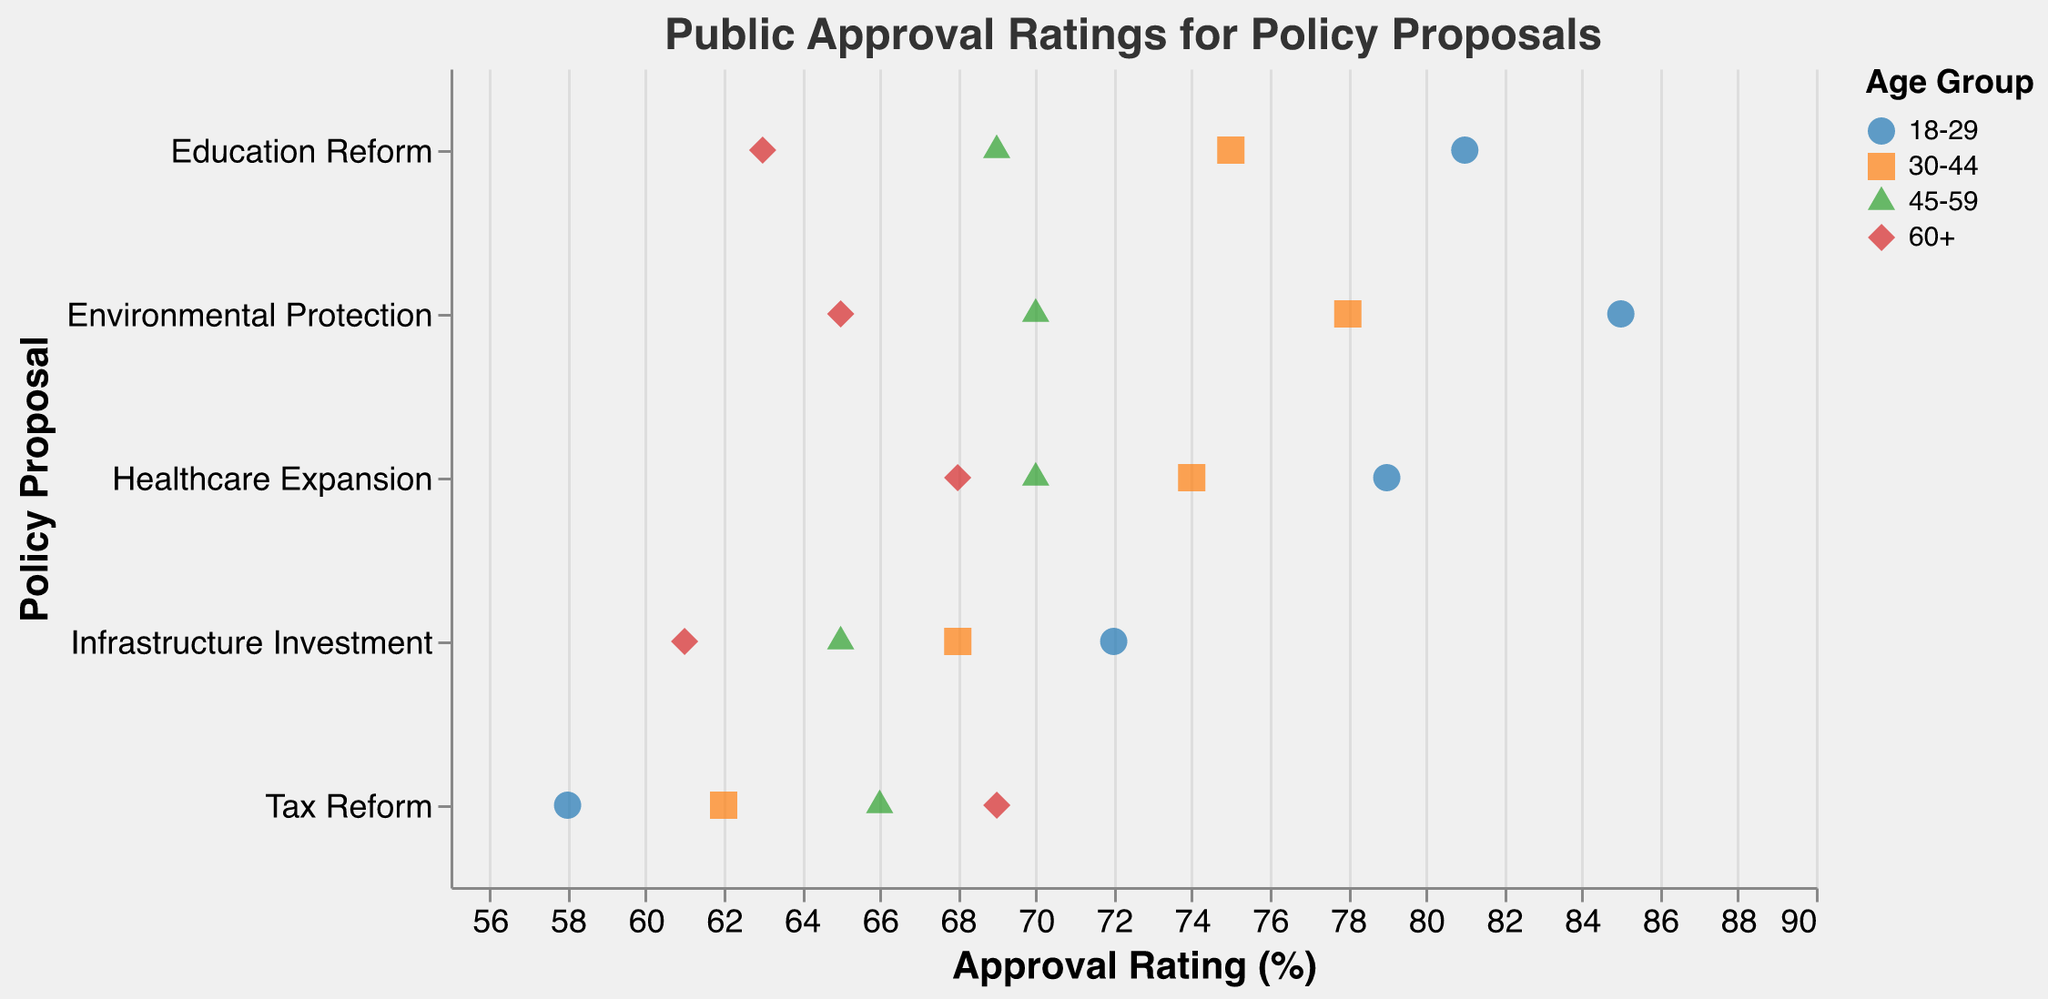What policy has the highest approval rating among the 18-29 age group? By closely examining the colored dots representing the 18-29 age group, we notice that the highest position on the x-axis indicates that "Environmental Protection" has the highest approval rating at 85.
Answer: Environmental Protection What is the approval rating difference for Tax Reform between the 18-29 and 60+ demographics? The approval rating for Tax Reform among the 18-29 demographic is 58, and for the 60+ demographic, it is 69. The difference is calculated by subtracting 58 from 69.
Answer: 11 Which policy shows the most significant decline in approval rating from the 18-29 demographic to the 60+ demographic? Comparing the approval ratings of all policies from the 18-29 to the 60+ demographic, "Education Reform" has ratings of 81 (18-29) and 63 (60+), giving a decline of 18 points which is the highest.
Answer: Education Reform How many policies have higher approval ratings for the 60+ demographic compared to the 18-29 demographic? By inspecting each policy visually, none of the policies show a higher approval rating for the 60+ demographic compared to the 18-29 demographic. Calculate the difference for each policy age group.
Answer: 0 Which demographic group shows the smallest variation in approval ratings across all policies? To determine this, calculate the range of approval ratings for each demographic. The demographic "60+" ranges from 61 to 69, "45-59" from 65 to 70, "30-44" from 62 to 75, and "18-29" from 58 to 85. The "45-59" group shows the smallest range.
Answer: 45-59 What is the mean approval rating of Healthcare Expansion for the 30-44 and 45-59 demographics? The approval ratings for Healthcare Expansion are 74 (30-44) and 70 (45-59). Calculate the mean by adding the two values and divide by 2: (74 + 70) / 2 = 72.
Answer: 72 Which policy has the closest approval rating between the 30-44 and 45-59 demographics? Healthcare Expansion has approval ratings of 74 (30-44) and 70 (45-59), with a difference of 4, the smallest among all policies when comparing these two demographics.
Answer: Healthcare Expansion What is the overall trend observed for the approval ratings across age demographics for Infrastructure Investment? The approval rating for Infrastructure Investment decreases as the age demographic increases: 72 (18-29), 68 (30-44), 65 (45-59), and 61 (60+). This indicates a downward trend in approval with increasing age.
Answer: Downward trend Which two policies have the highest and lowest overall approval ratings across all demographics? By comparing the average approval ratings across all policies, "Environmental Protection" generally scores highest, especially in the 18-29 group, and "Tax Reform" generally scores the lowest, particularly in the 18-29 group.
Answer: Environmental Protection, Tax Reform 